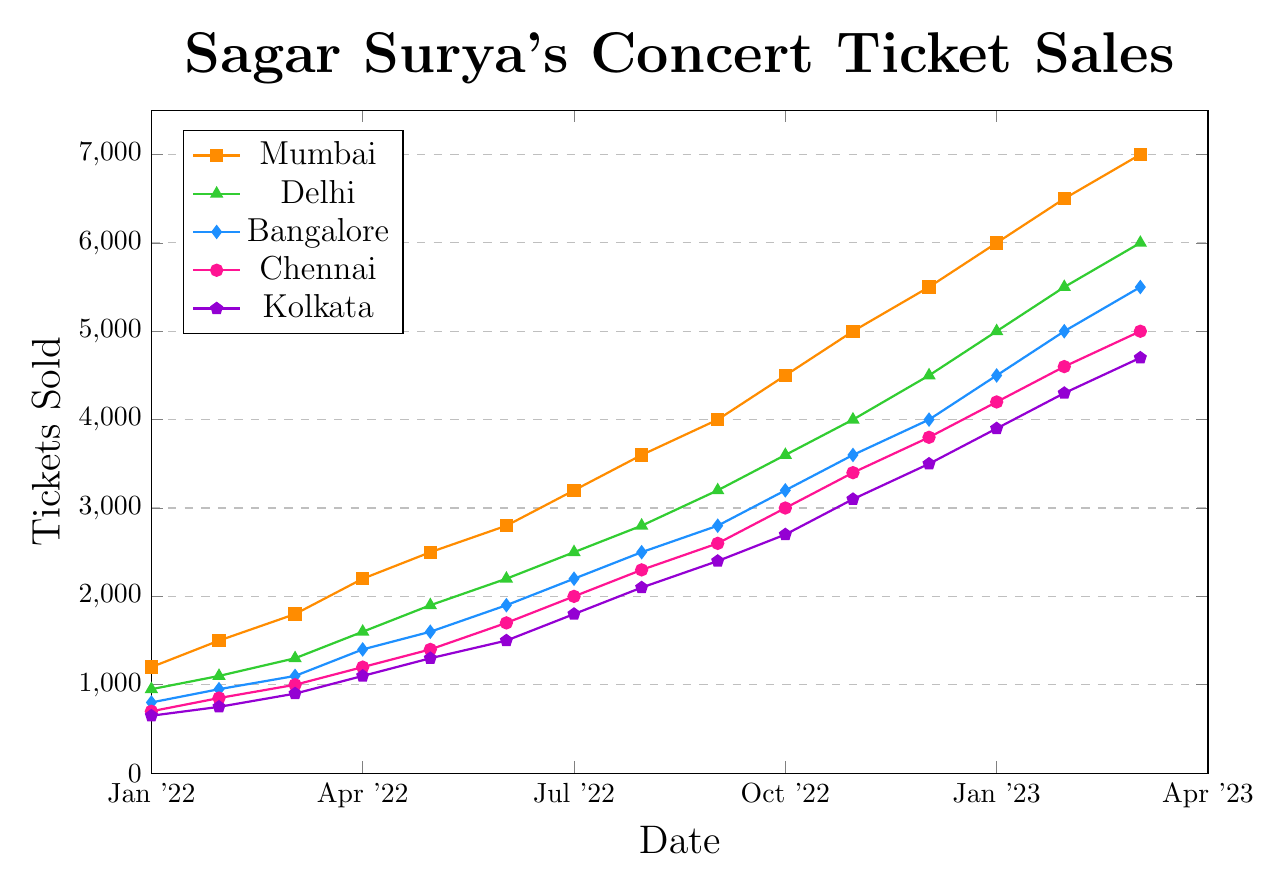Which city had the highest ticket sales in March 2022? From the figure, locate March 2022 on the x-axis and compare the ticket sales across all cities. Mumbai has the highest number at 1800 tickets.
Answer: Mumbai Which city's ticket sales increased the most between January 2022 and March 2023? From the figure, analyze the starting and ending ticket sales for each city from January 2022 to March 2023. For Mumbai, it increased from 1200 to 7000, which is an increase of 5800 tickets, the highest among all cities.
Answer: Mumbai In which month did Bangalore's ticket sales exceed 3000? Trace Bangalore's line in the figure and identify the first point where the value exceeds 3000 tickets. This occurs in October 2022.
Answer: October 2022 How many total tickets were sold in Chennai from January 2022 to March 2023? Sum up Chennai's monthly ticket sales: 700 + 850 + 1000 + 1200 + 1400 + 1700 + 2000 + 2300 + 2600 + 3000 + 3400 + 3800 + 4200 + 4600 + 5000 = 38250 tickets.
Answer: 38250 Which city showed the slowest growth in ticket sales over the time period? Compare the slope of the lines for each city. Kolkata's line starts at 650 and ends at 4700, showing the smallest difference of 4050 compared to other cities.
Answer: Kolkata What was the average monthly ticket sales for Delhi in 2022? Sum Delhi's monthly ticket sales for 2022 and divide by 12: (950 + 1100 + 1300 + 1600 + 1900 + 2200 + 2500 + 2800 + 3200 + 3600 + 4000 + 4500) / 12 = 2383.33
Answer: 2383.33 Between which consecutive months did Mumbai see the highest increase in ticket sales? Evaluate the differences between each pair of consecutive months for Mumbai, and the highest increase is between December 2022 and January 2023, where the increase is 500 tickets (5500 to 6000).
Answer: December 2022 to January 2023 What is the total ticket sales for all cities combined in February 2023? Sum the February 2023 ticket sales for all cities: 6500 (Mumbai) + 5500 (Delhi) + 5000 (Bangalore) + 4600 (Chennai) + 4300 (Kolkata) = 25900 tickets.
Answer: 25900 Which city had the highest growth rate in ticket sales from January to December 2022? Calculate the growth rate for each city and compare. Mumbai had a growth rate from 1200 in January to 5500 in December, an increase of 4300 tickets. This is the highest among all cities.
Answer: Mumbai What is the color used to represent Chennai in the chart? Look at the legend where each city is associated with a color. Chennai is represented by a pink color.
Answer: Pink 